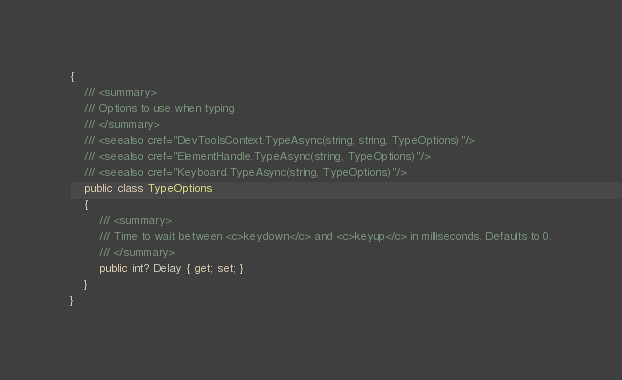<code> <loc_0><loc_0><loc_500><loc_500><_C#_>{
    /// <summary>
    /// Options to use when typing
    /// </summary>
    /// <seealso cref="DevToolsContext.TypeAsync(string, string, TypeOptions)"/>
    /// <seealso cref="ElementHandle.TypeAsync(string, TypeOptions)"/>
    /// <seealso cref="Keyboard.TypeAsync(string, TypeOptions)"/>
    public class TypeOptions
    {
        /// <summary>
        /// Time to wait between <c>keydown</c> and <c>keyup</c> in milliseconds. Defaults to 0.
        /// </summary>
        public int? Delay { get; set; }
    }
}</code> 